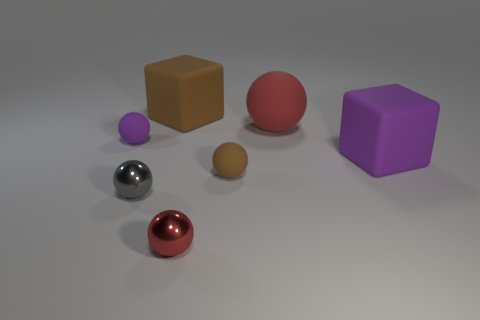What material is the red sphere in front of the big purple object behind the small brown matte thing made of?
Your answer should be very brief. Metal. How many other spheres are the same color as the large sphere?
Make the answer very short. 1. Are there fewer matte blocks that are to the right of the large brown matte object than brown objects?
Your response must be concise. Yes. What color is the rubber ball that is in front of the cube that is on the right side of the large red matte thing?
Keep it short and to the point. Brown. How big is the red object that is in front of the red rubber object that is to the left of the rubber block that is in front of the small purple object?
Your answer should be very brief. Small. Is the number of brown rubber objects that are on the left side of the purple rubber ball less than the number of rubber things that are on the left side of the small brown rubber thing?
Keep it short and to the point. Yes. How many brown things are the same material as the tiny red ball?
Provide a short and direct response. 0. Are there any tiny brown matte balls that are in front of the purple thing that is on the right side of the brown matte object to the right of the small red object?
Your response must be concise. Yes. There is a tiny brown object that is made of the same material as the purple block; what shape is it?
Your answer should be compact. Sphere. Is the number of large purple things greater than the number of red objects?
Keep it short and to the point. No. 